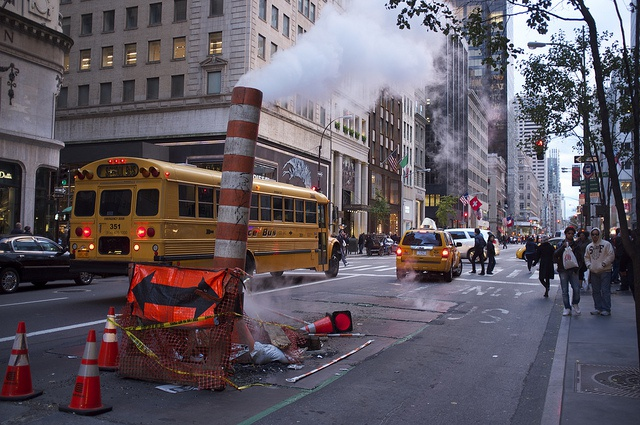Describe the objects in this image and their specific colors. I can see bus in gray, black, maroon, and brown tones, car in gray, black, and darkblue tones, car in gray, black, maroon, and brown tones, people in gray and black tones, and people in gray and black tones in this image. 